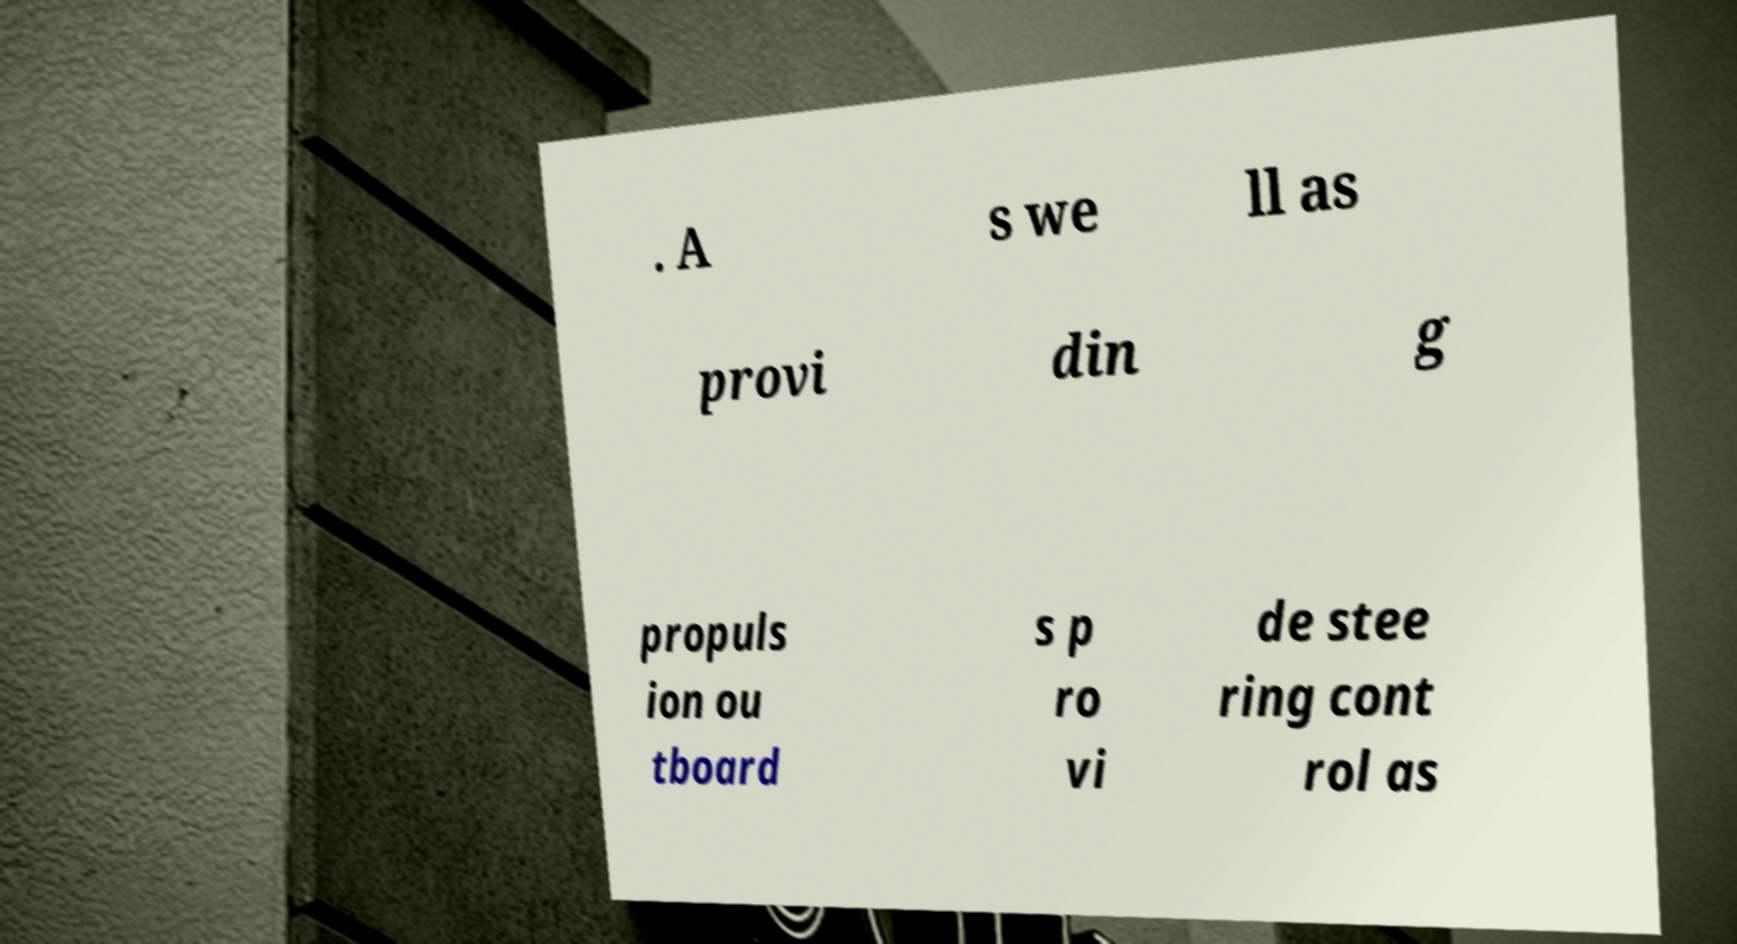Can you read and provide the text displayed in the image?This photo seems to have some interesting text. Can you extract and type it out for me? . A s we ll as provi din g propuls ion ou tboard s p ro vi de stee ring cont rol as 